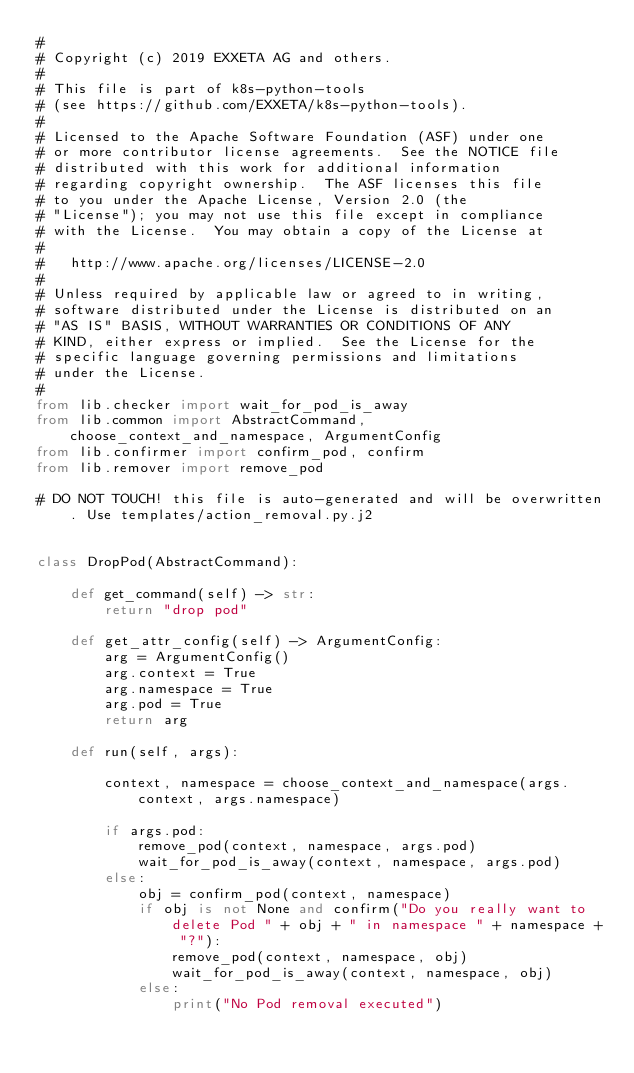<code> <loc_0><loc_0><loc_500><loc_500><_Python_>#
# Copyright (c) 2019 EXXETA AG and others.
#
# This file is part of k8s-python-tools
# (see https://github.com/EXXETA/k8s-python-tools).
#
# Licensed to the Apache Software Foundation (ASF) under one
# or more contributor license agreements.  See the NOTICE file
# distributed with this work for additional information
# regarding copyright ownership.  The ASF licenses this file
# to you under the Apache License, Version 2.0 (the
# "License"); you may not use this file except in compliance
# with the License.  You may obtain a copy of the License at
#
#   http://www.apache.org/licenses/LICENSE-2.0
#
# Unless required by applicable law or agreed to in writing,
# software distributed under the License is distributed on an
# "AS IS" BASIS, WITHOUT WARRANTIES OR CONDITIONS OF ANY
# KIND, either express or implied.  See the License for the
# specific language governing permissions and limitations
# under the License.
#
from lib.checker import wait_for_pod_is_away
from lib.common import AbstractCommand, choose_context_and_namespace, ArgumentConfig
from lib.confirmer import confirm_pod, confirm
from lib.remover import remove_pod

# DO NOT TOUCH! this file is auto-generated and will be overwritten. Use templates/action_removal.py.j2


class DropPod(AbstractCommand):

    def get_command(self) -> str:
        return "drop pod"

    def get_attr_config(self) -> ArgumentConfig:
        arg = ArgumentConfig()
        arg.context = True
        arg.namespace = True
        arg.pod = True
        return arg

    def run(self, args):
        
        context, namespace = choose_context_and_namespace(args.context, args.namespace)

        if args.pod:
            remove_pod(context, namespace, args.pod)
            wait_for_pod_is_away(context, namespace, args.pod)
        else:
            obj = confirm_pod(context, namespace)
            if obj is not None and confirm("Do you really want to delete Pod " + obj + " in namespace " + namespace + "?"):
                remove_pod(context, namespace, obj)
                wait_for_pod_is_away(context, namespace, obj)
            else:
                print("No Pod removal executed")
        </code> 